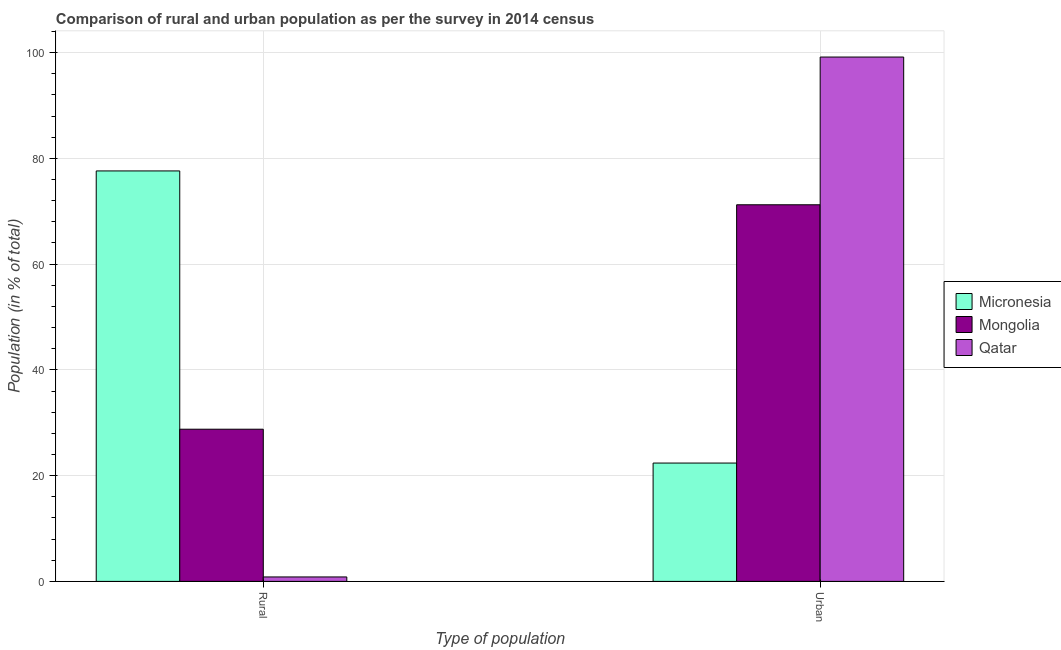How many different coloured bars are there?
Keep it short and to the point. 3. How many bars are there on the 2nd tick from the left?
Your answer should be very brief. 3. What is the label of the 1st group of bars from the left?
Your answer should be compact. Rural. What is the urban population in Qatar?
Your response must be concise. 99.16. Across all countries, what is the maximum rural population?
Offer a terse response. 77.62. Across all countries, what is the minimum rural population?
Provide a succinct answer. 0.84. In which country was the urban population maximum?
Keep it short and to the point. Qatar. In which country was the urban population minimum?
Make the answer very short. Micronesia. What is the total rural population in the graph?
Give a very brief answer. 107.24. What is the difference between the urban population in Qatar and that in Micronesia?
Make the answer very short. 76.78. What is the difference between the urban population in Micronesia and the rural population in Qatar?
Provide a short and direct response. 21.54. What is the average rural population per country?
Provide a succinct answer. 35.75. What is the difference between the rural population and urban population in Micronesia?
Offer a very short reply. 55.24. In how many countries, is the urban population greater than 44 %?
Your answer should be very brief. 2. What is the ratio of the rural population in Micronesia to that in Qatar?
Your answer should be very brief. 92.3. In how many countries, is the urban population greater than the average urban population taken over all countries?
Your answer should be compact. 2. What does the 1st bar from the left in Rural represents?
Ensure brevity in your answer.  Micronesia. What does the 1st bar from the right in Rural represents?
Provide a short and direct response. Qatar. How many bars are there?
Provide a succinct answer. 6. Are all the bars in the graph horizontal?
Make the answer very short. No. How many countries are there in the graph?
Offer a terse response. 3. Does the graph contain any zero values?
Provide a short and direct response. No. How are the legend labels stacked?
Offer a very short reply. Vertical. What is the title of the graph?
Provide a succinct answer. Comparison of rural and urban population as per the survey in 2014 census. Does "Canada" appear as one of the legend labels in the graph?
Offer a terse response. No. What is the label or title of the X-axis?
Provide a succinct answer. Type of population. What is the label or title of the Y-axis?
Provide a short and direct response. Population (in % of total). What is the Population (in % of total) of Micronesia in Rural?
Your answer should be very brief. 77.62. What is the Population (in % of total) of Mongolia in Rural?
Your answer should be compact. 28.78. What is the Population (in % of total) of Qatar in Rural?
Make the answer very short. 0.84. What is the Population (in % of total) in Micronesia in Urban?
Keep it short and to the point. 22.38. What is the Population (in % of total) of Mongolia in Urban?
Provide a succinct answer. 71.22. What is the Population (in % of total) of Qatar in Urban?
Keep it short and to the point. 99.16. Across all Type of population, what is the maximum Population (in % of total) of Micronesia?
Your answer should be very brief. 77.62. Across all Type of population, what is the maximum Population (in % of total) in Mongolia?
Ensure brevity in your answer.  71.22. Across all Type of population, what is the maximum Population (in % of total) in Qatar?
Offer a terse response. 99.16. Across all Type of population, what is the minimum Population (in % of total) in Micronesia?
Give a very brief answer. 22.38. Across all Type of population, what is the minimum Population (in % of total) of Mongolia?
Provide a short and direct response. 28.78. Across all Type of population, what is the minimum Population (in % of total) of Qatar?
Your response must be concise. 0.84. What is the total Population (in % of total) in Mongolia in the graph?
Your response must be concise. 100. What is the difference between the Population (in % of total) in Micronesia in Rural and that in Urban?
Your response must be concise. 55.24. What is the difference between the Population (in % of total) of Mongolia in Rural and that in Urban?
Your answer should be compact. -42.44. What is the difference between the Population (in % of total) of Qatar in Rural and that in Urban?
Offer a very short reply. -98.32. What is the difference between the Population (in % of total) in Micronesia in Rural and the Population (in % of total) in Mongolia in Urban?
Your answer should be compact. 6.4. What is the difference between the Population (in % of total) of Micronesia in Rural and the Population (in % of total) of Qatar in Urban?
Offer a very short reply. -21.54. What is the difference between the Population (in % of total) in Mongolia in Rural and the Population (in % of total) in Qatar in Urban?
Offer a terse response. -70.38. What is the average Population (in % of total) in Mongolia per Type of population?
Offer a very short reply. 50. What is the difference between the Population (in % of total) of Micronesia and Population (in % of total) of Mongolia in Rural?
Make the answer very short. 48.84. What is the difference between the Population (in % of total) in Micronesia and Population (in % of total) in Qatar in Rural?
Your answer should be compact. 76.78. What is the difference between the Population (in % of total) in Mongolia and Population (in % of total) in Qatar in Rural?
Give a very brief answer. 27.94. What is the difference between the Population (in % of total) of Micronesia and Population (in % of total) of Mongolia in Urban?
Provide a succinct answer. -48.84. What is the difference between the Population (in % of total) in Micronesia and Population (in % of total) in Qatar in Urban?
Keep it short and to the point. -76.78. What is the difference between the Population (in % of total) in Mongolia and Population (in % of total) in Qatar in Urban?
Your response must be concise. -27.94. What is the ratio of the Population (in % of total) in Micronesia in Rural to that in Urban?
Your answer should be compact. 3.47. What is the ratio of the Population (in % of total) of Mongolia in Rural to that in Urban?
Your answer should be very brief. 0.4. What is the ratio of the Population (in % of total) of Qatar in Rural to that in Urban?
Your answer should be compact. 0.01. What is the difference between the highest and the second highest Population (in % of total) of Micronesia?
Provide a short and direct response. 55.24. What is the difference between the highest and the second highest Population (in % of total) in Mongolia?
Your response must be concise. 42.44. What is the difference between the highest and the second highest Population (in % of total) of Qatar?
Your response must be concise. 98.32. What is the difference between the highest and the lowest Population (in % of total) of Micronesia?
Your answer should be compact. 55.24. What is the difference between the highest and the lowest Population (in % of total) in Mongolia?
Provide a short and direct response. 42.44. What is the difference between the highest and the lowest Population (in % of total) of Qatar?
Make the answer very short. 98.32. 